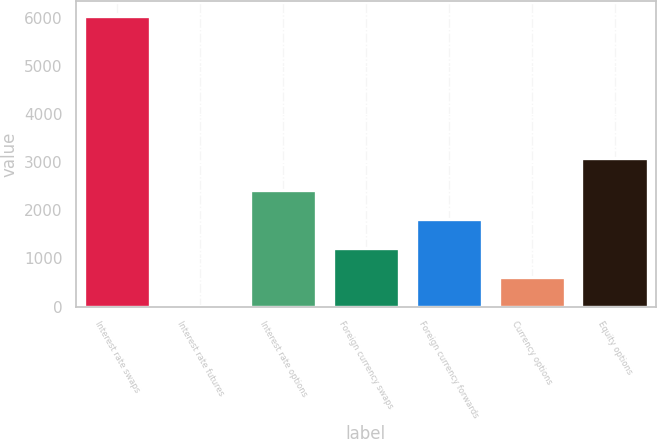Convert chart to OTSL. <chart><loc_0><loc_0><loc_500><loc_500><bar_chart><fcel>Interest rate swaps<fcel>Interest rate futures<fcel>Interest rate options<fcel>Foreign currency swaps<fcel>Foreign currency forwards<fcel>Currency options<fcel>Equity options<nl><fcel>6042<fcel>6<fcel>2420.4<fcel>1213.2<fcel>1816.8<fcel>609.6<fcel>3084<nl></chart> 